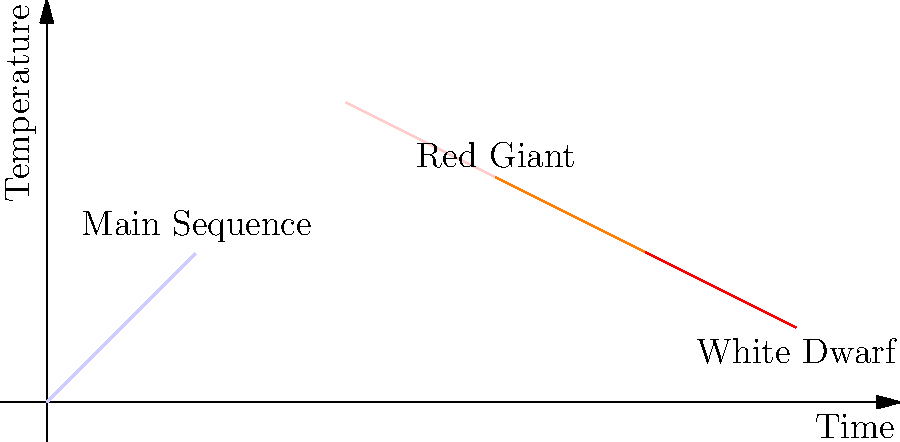In GLSL, how would you create a smooth color transition to represent the temperature changes in a star's life cycle, as shown in the graph? Consider using the mix() function and time-based animation. To create a smooth color transition representing a star's life cycle in GLSL, follow these steps:

1. Define color variables for each stage of the star's life:
   ```glsl
   vec3 mainSequence = vec3(1.0, 1.0, 1.0);  // White
   vec3 redGiant = vec3(1.0, 0.5, 0.0);      // Orange
   vec3 whiteDwarf = vec3(0.5, 0.5, 1.0);    // Light Blue
   ```

2. Use a time-based variable to control the progression of the life cycle:
   ```glsl
   uniform float time;  // Assumes time is passed in as a uniform
   float lifecycle = fract(time * 0.1);  // Repeats every 10 seconds
   ```

3. Use conditional statements with the mix() function to blend between colors:
   ```glsl
   vec3 starColor;
   if (lifecycle < 0.5) {
       starColor = mix(mainSequence, redGiant, lifecycle * 2.0);
   } else {
       starColor = mix(redGiant, whiteDwarf, (lifecycle - 0.5) * 2.0);
   }
   ```

4. Apply the resulting color to your star fragment:
   ```glsl
   gl_FragColor = vec4(starColor, 1.0);
   ```

This approach creates a smooth transition from white (main sequence) to orange (red giant) to light blue (white dwarf), representing the temperature changes throughout the star's life cycle.
Answer: Use mix() function with time-based animation to blend between predefined color stages (white, orange, light blue). 